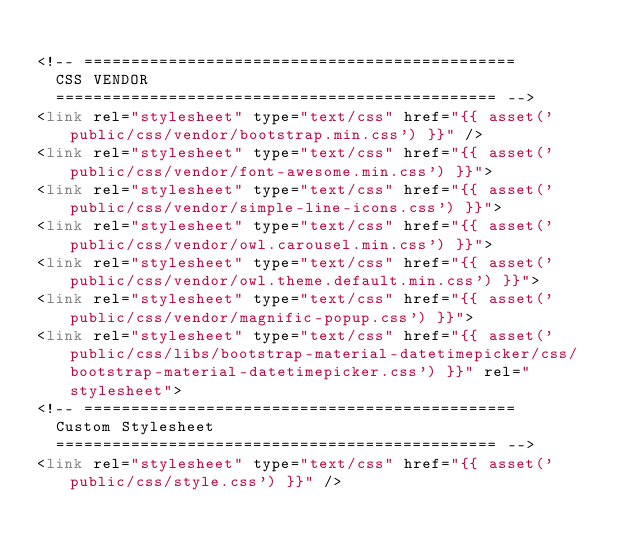<code> <loc_0><loc_0><loc_500><loc_500><_PHP_>
<!-- ==============================================
	CSS VENDOR
	=============================================== -->
<link rel="stylesheet" type="text/css" href="{{ asset('public/css/vendor/bootstrap.min.css') }}" />
<link rel="stylesheet" type="text/css" href="{{ asset('public/css/vendor/font-awesome.min.css') }}">
<link rel="stylesheet" type="text/css" href="{{ asset('public/css/vendor/simple-line-icons.css') }}">
<link rel="stylesheet" type="text/css" href="{{ asset('public/css/vendor/owl.carousel.min.css') }}">
<link rel="stylesheet" type="text/css" href="{{ asset('public/css/vendor/owl.theme.default.min.css') }}">
<link rel="stylesheet" type="text/css" href="{{ asset('public/css/vendor/magnific-popup.css') }}">
<link rel="stylesheet" type="text/css" href="{{ asset('public/css/libs/bootstrap-material-datetimepicker/css/bootstrap-material-datetimepicker.css') }}" rel="stylesheet">
<!-- ==============================================
	Custom Stylesheet
	=============================================== -->
<link rel="stylesheet" type="text/css" href="{{ asset('public/css/style.css') }}" /></code> 